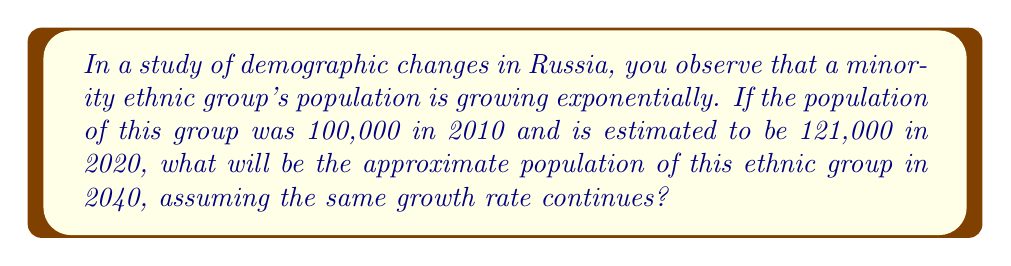Provide a solution to this math problem. To solve this problem, we need to use the exponential growth formula:

$$ A = P(1 + r)^t $$

Where:
$A$ is the final amount
$P$ is the initial principal (starting amount)
$r$ is the growth rate (as a decimal)
$t$ is the time in years

Step 1: Determine the growth rate
We know that from 2010 to 2020 (10 years), the population grew from 100,000 to 121,000.

$$ 121,000 = 100,000(1 + r)^{10} $$

Dividing both sides by 100,000:

$$ 1.21 = (1 + r)^{10} $$

Taking the 10th root of both sides:

$$ \sqrt[10]{1.21} = 1 + r $$

$$ 1.0193 = 1 + r $$

$$ r = 0.0193 \approx 1.93\% $$

Step 2: Calculate the population in 2040
Now that we have the growth rate, we can use the exponential growth formula to calculate the population in 2040, which is 30 years from 2010.

$$ A = 100,000(1 + 0.0193)^{30} $$

$$ A = 100,000(1.0193)^{30} $$

$$ A = 100,000(1.7742) $$

$$ A = 177,420 $$

Therefore, the approximate population of this ethnic group in 2040 will be 177,420.
Answer: 177,420 